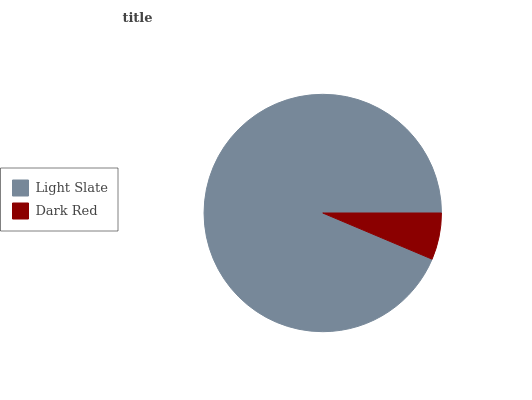Is Dark Red the minimum?
Answer yes or no. Yes. Is Light Slate the maximum?
Answer yes or no. Yes. Is Dark Red the maximum?
Answer yes or no. No. Is Light Slate greater than Dark Red?
Answer yes or no. Yes. Is Dark Red less than Light Slate?
Answer yes or no. Yes. Is Dark Red greater than Light Slate?
Answer yes or no. No. Is Light Slate less than Dark Red?
Answer yes or no. No. Is Light Slate the high median?
Answer yes or no. Yes. Is Dark Red the low median?
Answer yes or no. Yes. Is Dark Red the high median?
Answer yes or no. No. Is Light Slate the low median?
Answer yes or no. No. 